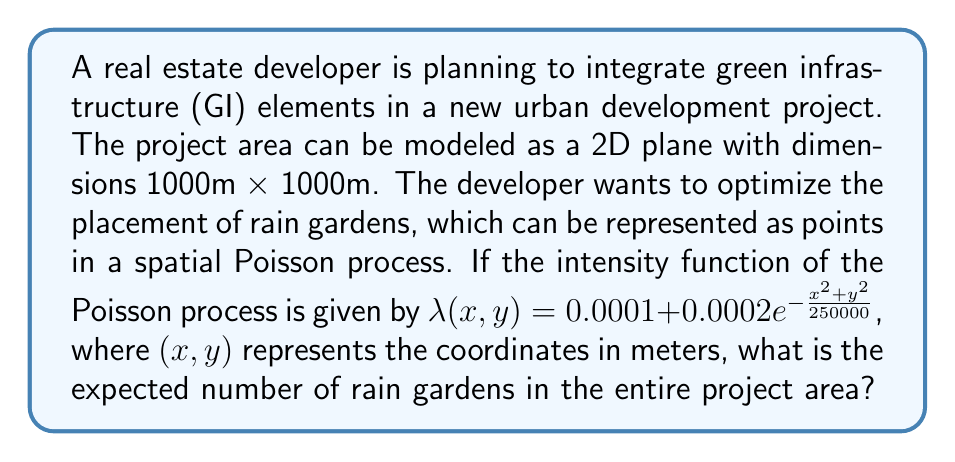Provide a solution to this math problem. To solve this problem, we need to follow these steps:

1) The expected number of points (rain gardens) in a spatial Poisson process over a region A is given by the integral of the intensity function over that region:

   $$E[N(A)] = \int\int_A \lambda(x,y) dxdy$$

2) In this case, our region A is a 1000m x 1000m square, so we need to integrate from 0 to 1000 for both x and y:

   $$E[N(A)] = \int_0^{1000}\int_0^{1000} (0.0001 + 0.0002e^{-\frac{x^2+y^2}{250000}}) dxdy$$

3) Let's separate this into two integrals:

   $$E[N(A)] = \int_0^{1000}\int_0^{1000} 0.0001 dxdy + \int_0^{1000}\int_0^{1000} 0.0002e^{-\frac{x^2+y^2}{250000}} dxdy$$

4) The first integral is straightforward:

   $$\int_0^{1000}\int_0^{1000} 0.0001 dxdy = 0.0001 \cdot 1000 \cdot 1000 = 100$$

5) For the second integral, we can use polar coordinates. Let $r^2 = x^2 + y^2$, then:

   $$\int_0^{1000}\int_0^{1000} 0.0002e^{-\frac{x^2+y^2}{250000}} dxdy = \int_0^{2\pi}\int_0^{1000\sqrt{2}} 0.0002e^{-\frac{r^2}{250000}} rdrd\theta$$

6) Solving this integral:

   $$= 2\pi \cdot 0.0002 \cdot 250000 \cdot (1 - e^{-\frac{2000000}{250000}}) \approx 314.13$$

7) The total expected number is the sum of these two results:

   $$E[N(A)] = 100 + 314.13 = 414.13$$
Answer: 414.13 rain gardens 